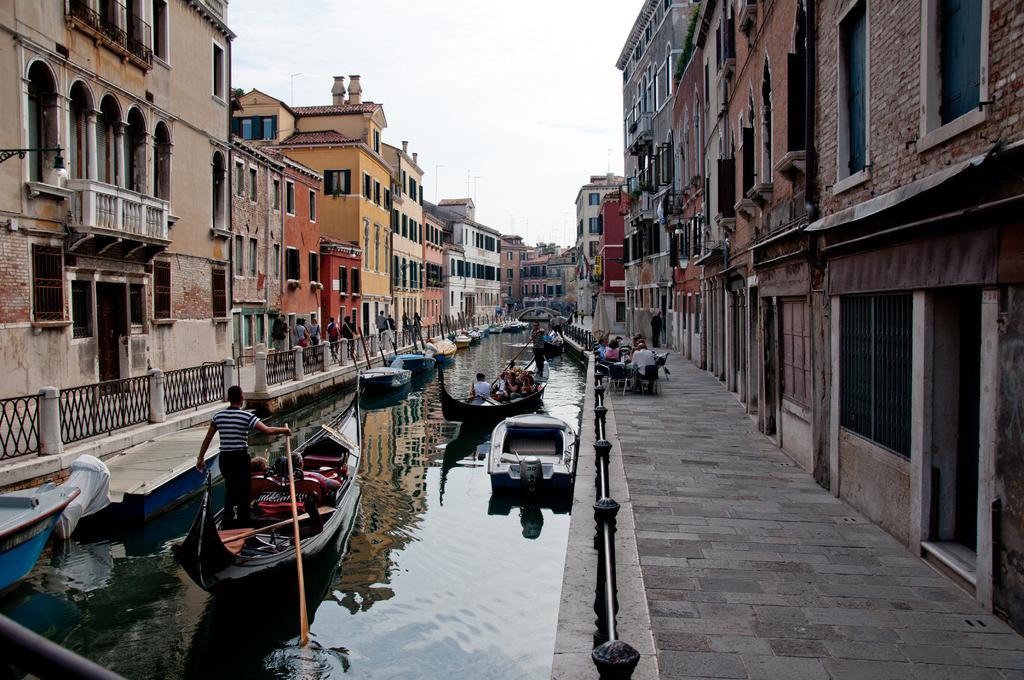Can you describe this image briefly? In this image, we can see some water in between the buildings and the boats are sailing on the water. There are few people in the boats and some of them are sitting and walking in front of the buildings. 